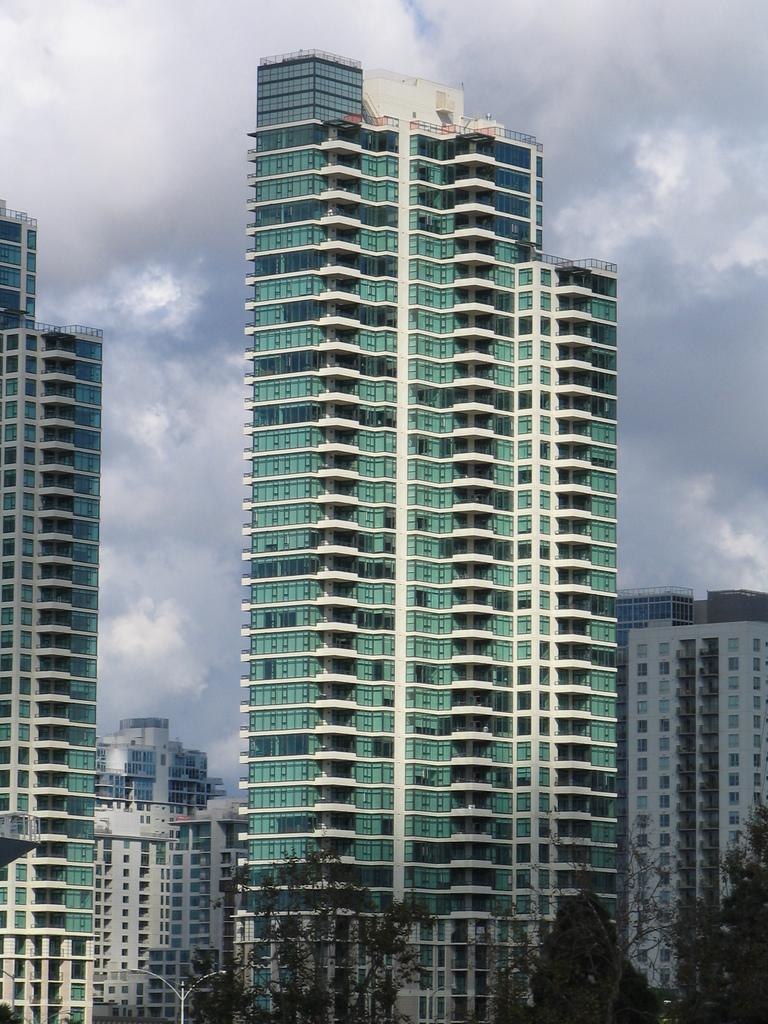What type of structures can be seen in the image? There are many buildings in the image. What type of vegetation is present at the bottom of the image? There are trees at the bottom of the image. What object is providing light in the image? There is a light pole in the image. What can be seen in the background of the image? The sky is visible in the background of the image. What is present in the sky? Clouds are present in the sky. How many dogs are visible in the image? There are no dogs present in the image. What type of operation is being performed on the buildings in the image? There is no operation being performed on the buildings in the image; they are simply standing. 